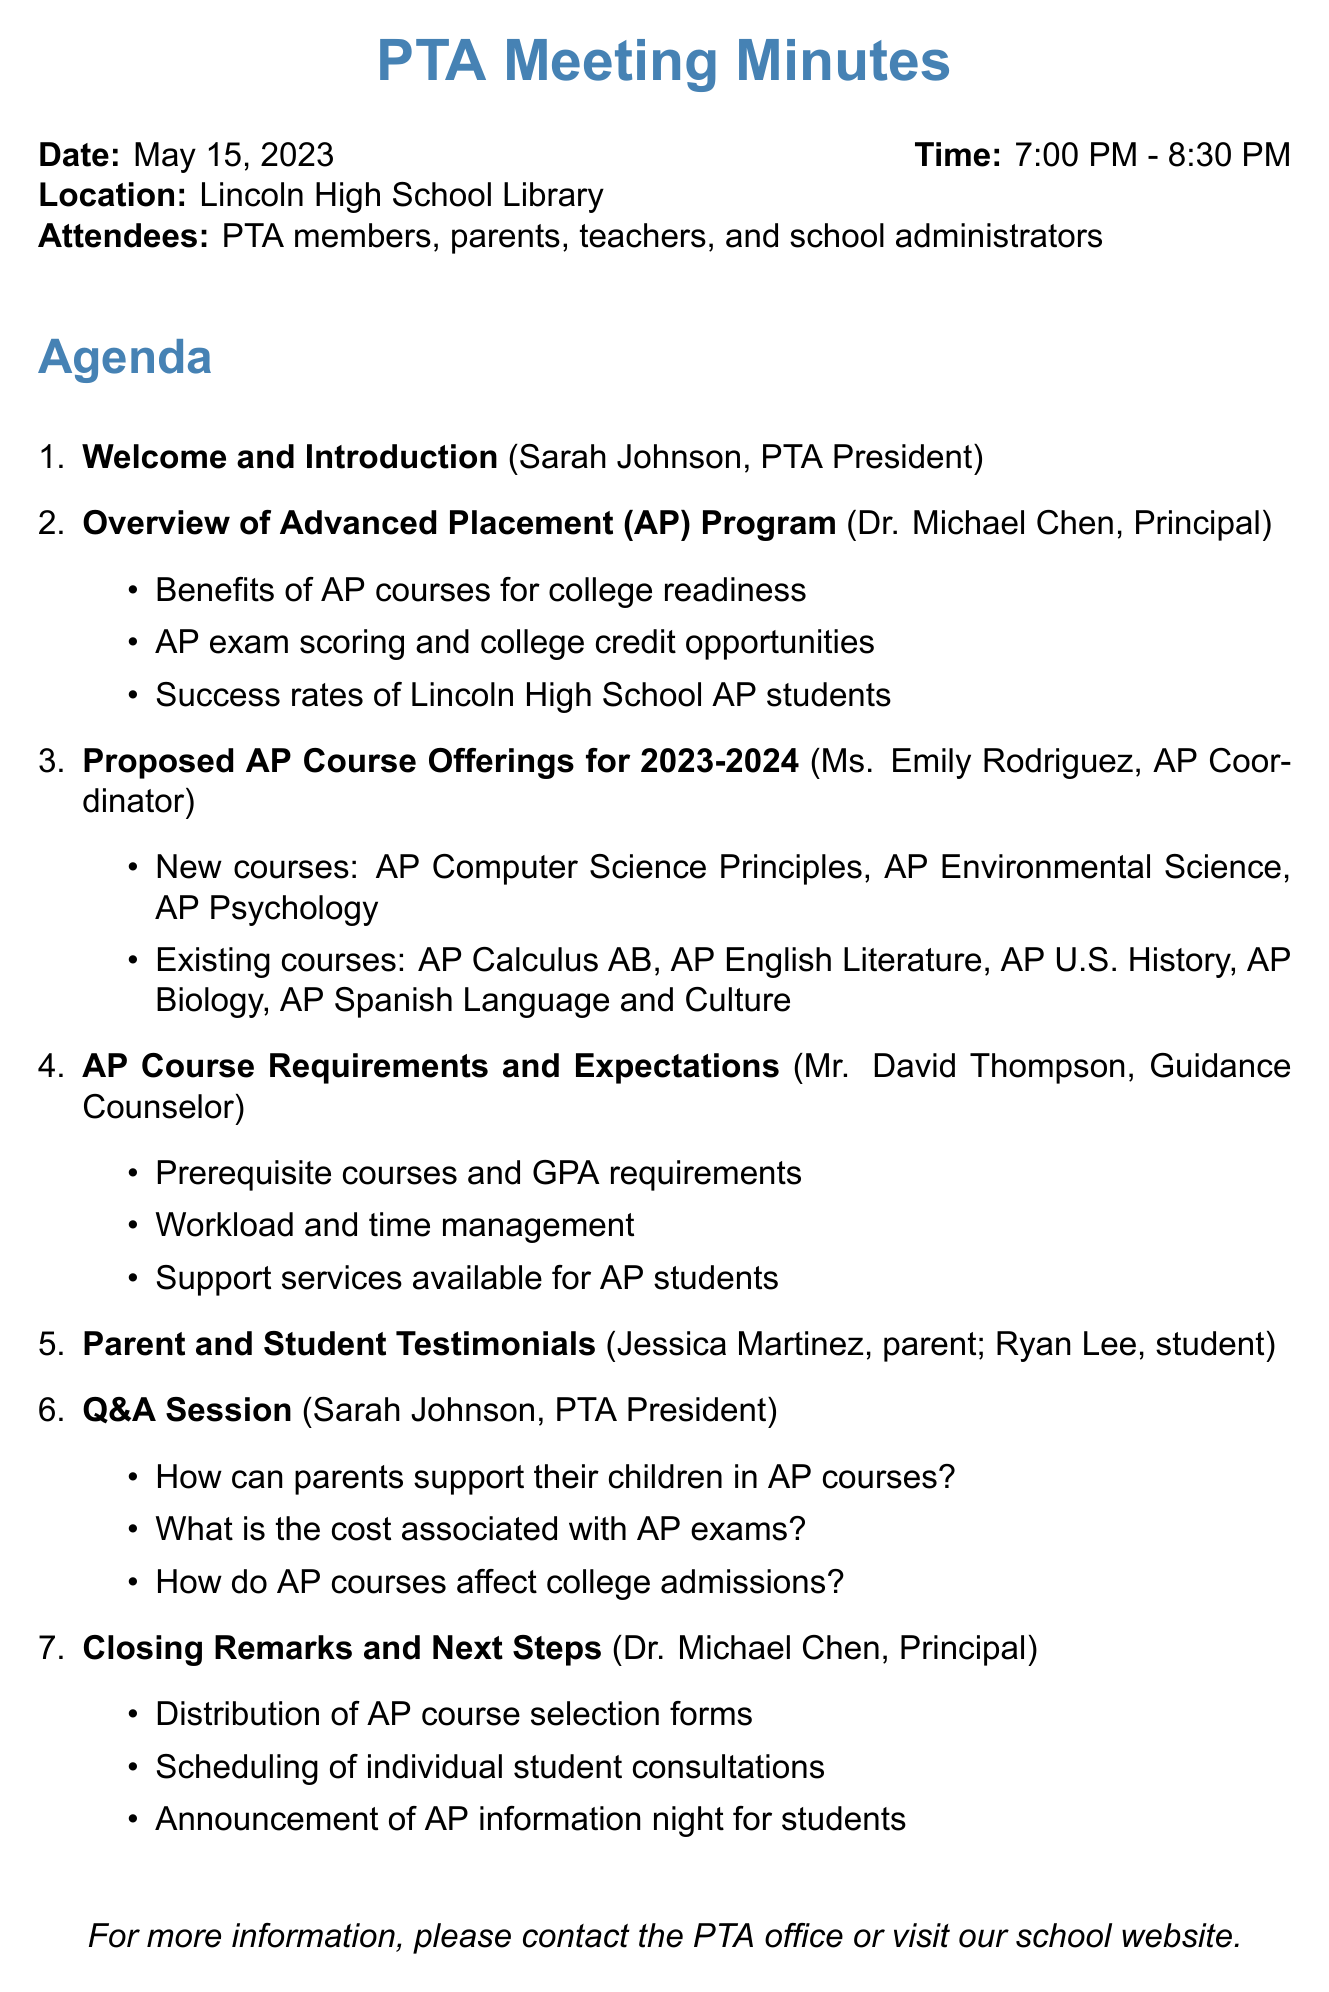What date was the meeting held? The meeting date is listed in the document as May 15, 2023.
Answer: May 15, 2023 Who presented the overview of the Advanced Placement Program? The document specifies that Dr. Michael Chen, the Principal, gave the overview.
Answer: Dr. Michael Chen How many minutes was allocated for the Q&A session? The document states that the Q&A session lasted for 25 minutes.
Answer: 25 minutes Name one of the new AP courses proposed for the upcoming academic year. The document lists several new courses, including AP Computer Science Principles.
Answer: AP Computer Science Principles What is one of the key points discussed regarding AP course requirements? One of the key points shared by Mr. David Thompson mentions prerequisite courses and GPA requirements.
Answer: Prerequisite courses and GPA requirements What action items were mentioned during the closing remarks? The document lists action items such as distribution of AP course selection forms and scheduling individual student consultations.
Answer: Distribution of AP course selection forms What percentage of meeting duration was allocated for introductions and welcome? The welcome and introduction segment lasted for 5 minutes out of a total of 90 minutes.
Answer: 5 minutes Who provided testimonials during the meeting? The document names Jessica Martinez and Ryan Lee as the individuals who provided testimonials.
Answer: Jessica Martinez, Ryan Lee What is one question sample from the Q&A session? The document includes sample questions, one being "How can parents support their children in AP courses?"
Answer: How can parents support their children in AP courses? 